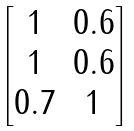Convert formula to latex. <formula><loc_0><loc_0><loc_500><loc_500>\begin{bmatrix} 1 & 0 . 6 \\ 1 & 0 . 6 \\ 0 . 7 & 1 \end{bmatrix}</formula> 